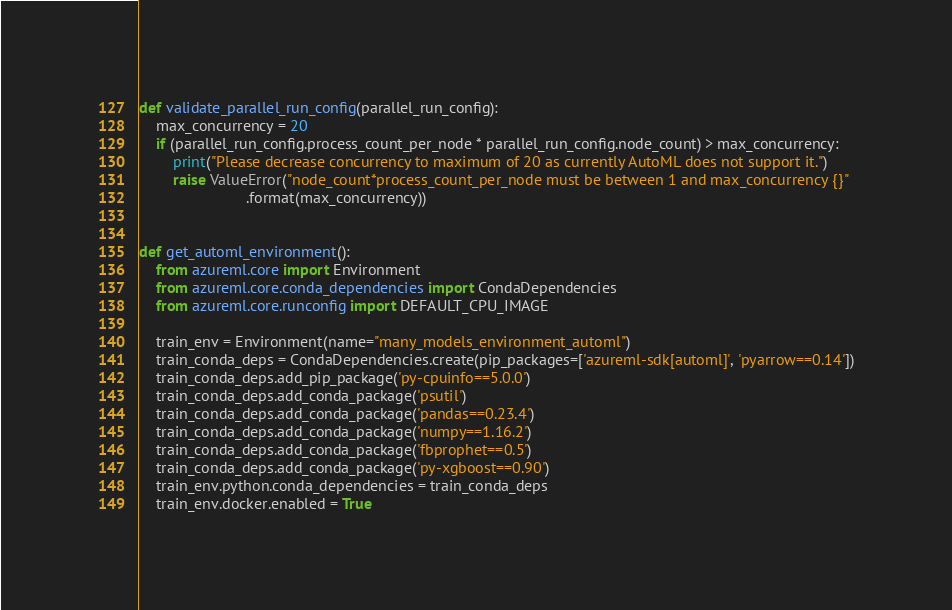Convert code to text. <code><loc_0><loc_0><loc_500><loc_500><_Python_>
def validate_parallel_run_config(parallel_run_config):
    max_concurrency = 20
    if (parallel_run_config.process_count_per_node * parallel_run_config.node_count) > max_concurrency:
        print("Please decrease concurrency to maximum of 20 as currently AutoML does not support it.")
        raise ValueError("node_count*process_count_per_node must be between 1 and max_concurrency {}"
                         .format(max_concurrency))


def get_automl_environment():
    from azureml.core import Environment
    from azureml.core.conda_dependencies import CondaDependencies
    from azureml.core.runconfig import DEFAULT_CPU_IMAGE

    train_env = Environment(name="many_models_environment_automl")
    train_conda_deps = CondaDependencies.create(pip_packages=['azureml-sdk[automl]', 'pyarrow==0.14'])
    train_conda_deps.add_pip_package('py-cpuinfo==5.0.0')
    train_conda_deps.add_conda_package('psutil')
    train_conda_deps.add_conda_package('pandas==0.23.4')
    train_conda_deps.add_conda_package('numpy==1.16.2')
    train_conda_deps.add_conda_package('fbprophet==0.5')
    train_conda_deps.add_conda_package('py-xgboost==0.90')
    train_env.python.conda_dependencies = train_conda_deps
    train_env.docker.enabled = True</code> 